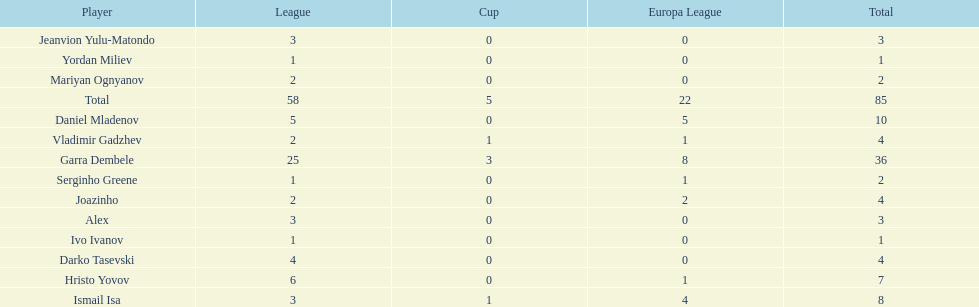How many goals did ismail isa score this season? 8. 